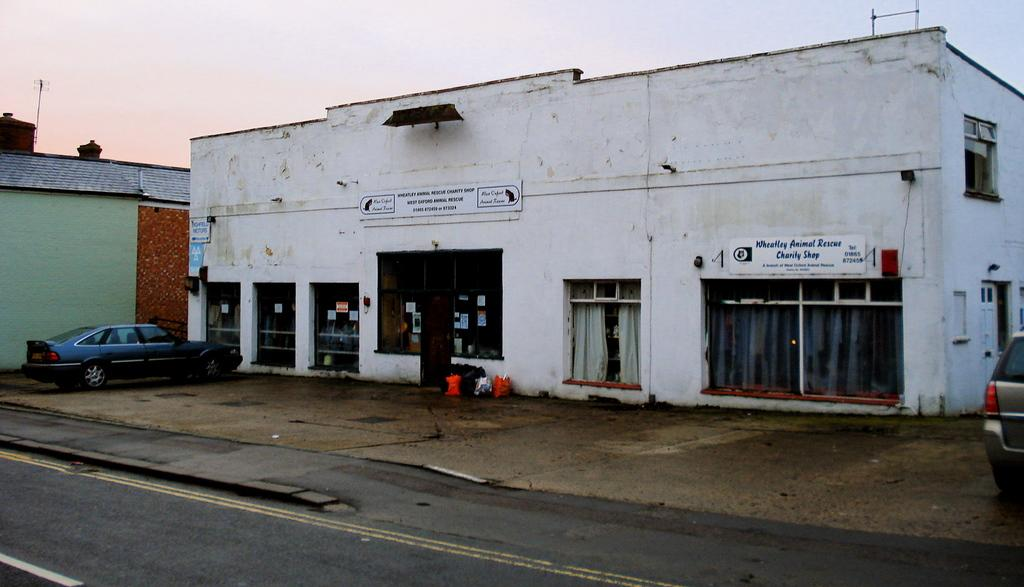What type of structures are present in the image? There are sheds in the image. What else can be seen in the image besides the sheds? There are poles, name boards, and windows visible in the image. What objects are located at the bottom of the image? There are objects at the bottom of the image, but their specific details are not mentioned in the facts. What is happening on the road in the image? There are vehicles on the road in the image. What is visible at the top of the image? The sky is visible at the top of the image. Can you tell me how the father is helping with the teaching in the image? There is no father or teaching activity present in the image. 